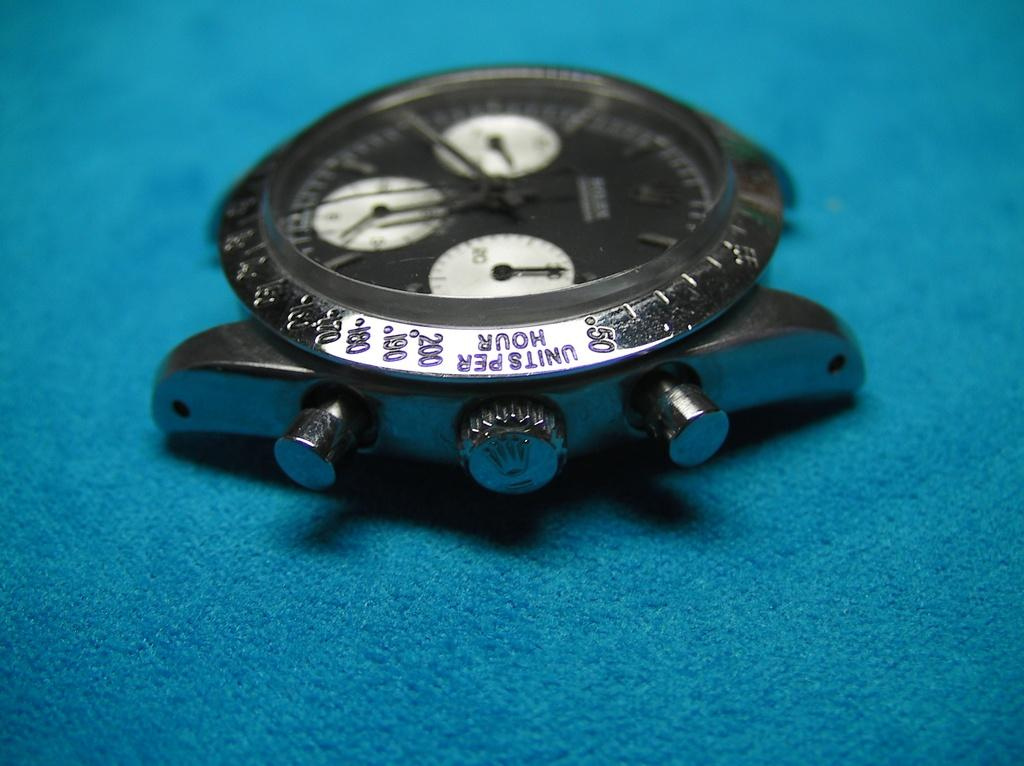<image>
Offer a succinct explanation of the picture presented. A watch with no band on it that says Units per hour next to the twisty dial. 